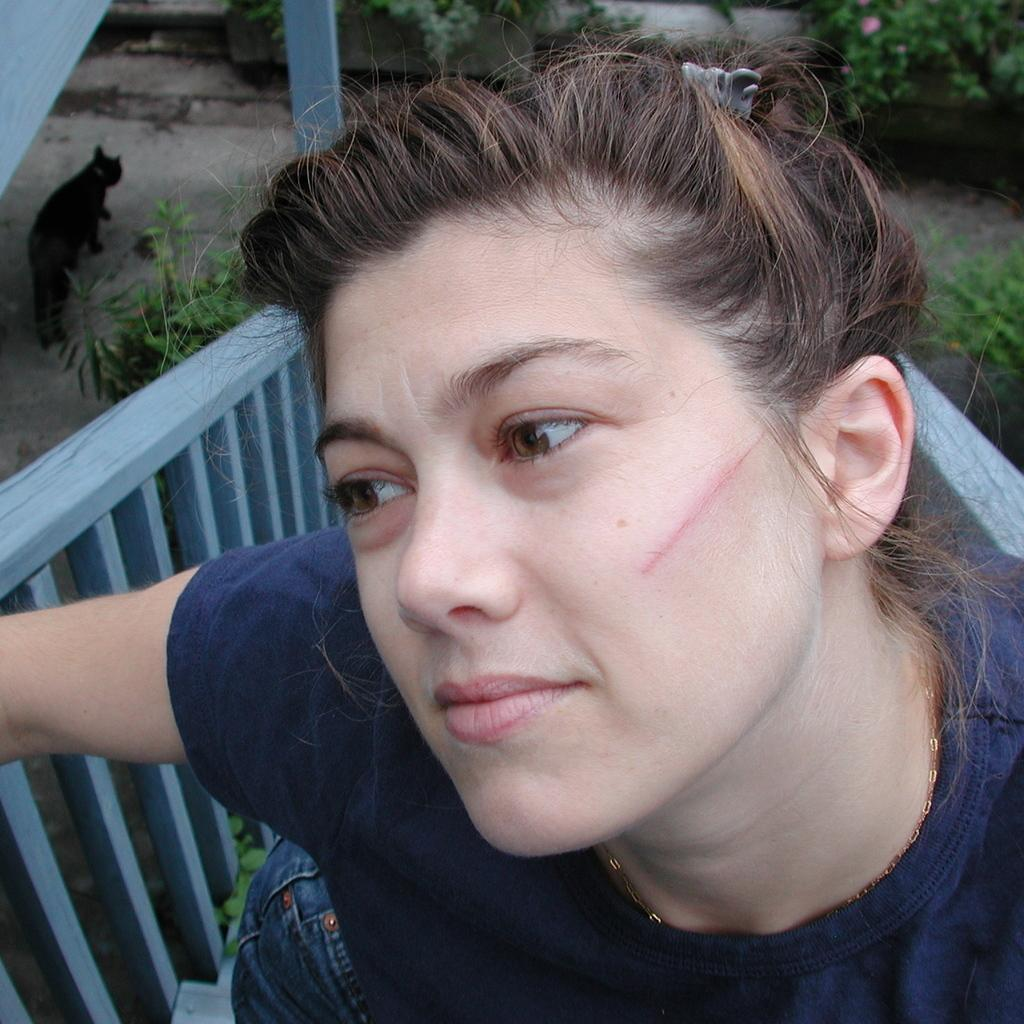Who is present in the image? There is a woman in the image. Can you describe any distinguishing features of the woman? The woman has a red line on her cheek. What can be seen in the background of the image? There are railings, a black color cat, and plants in the background of the image. What type of snake can be seen slithering near the woman in the image? There is no snake present in the image; it only features a woman with a red line on her cheek, railings, a black color cat, and plants in the background. 